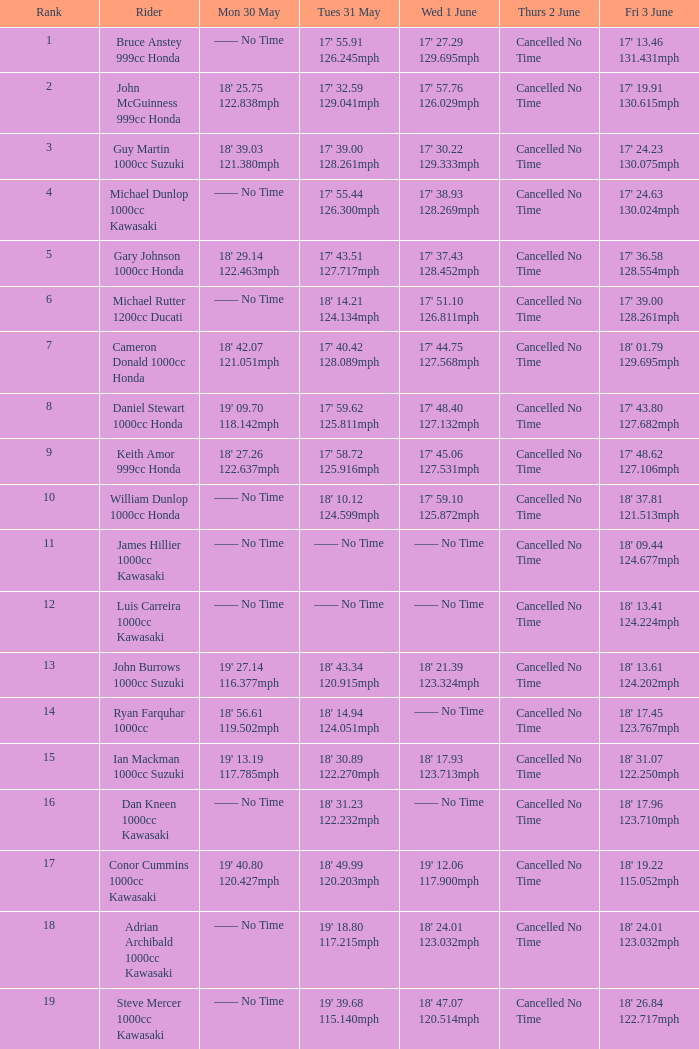What is the time for the rider on friday, june 3rd, who had a time of 19' 18.80 and a speed of 117.215 mph on tuesday, may 31st? 18' 24.01 123.032mph. 